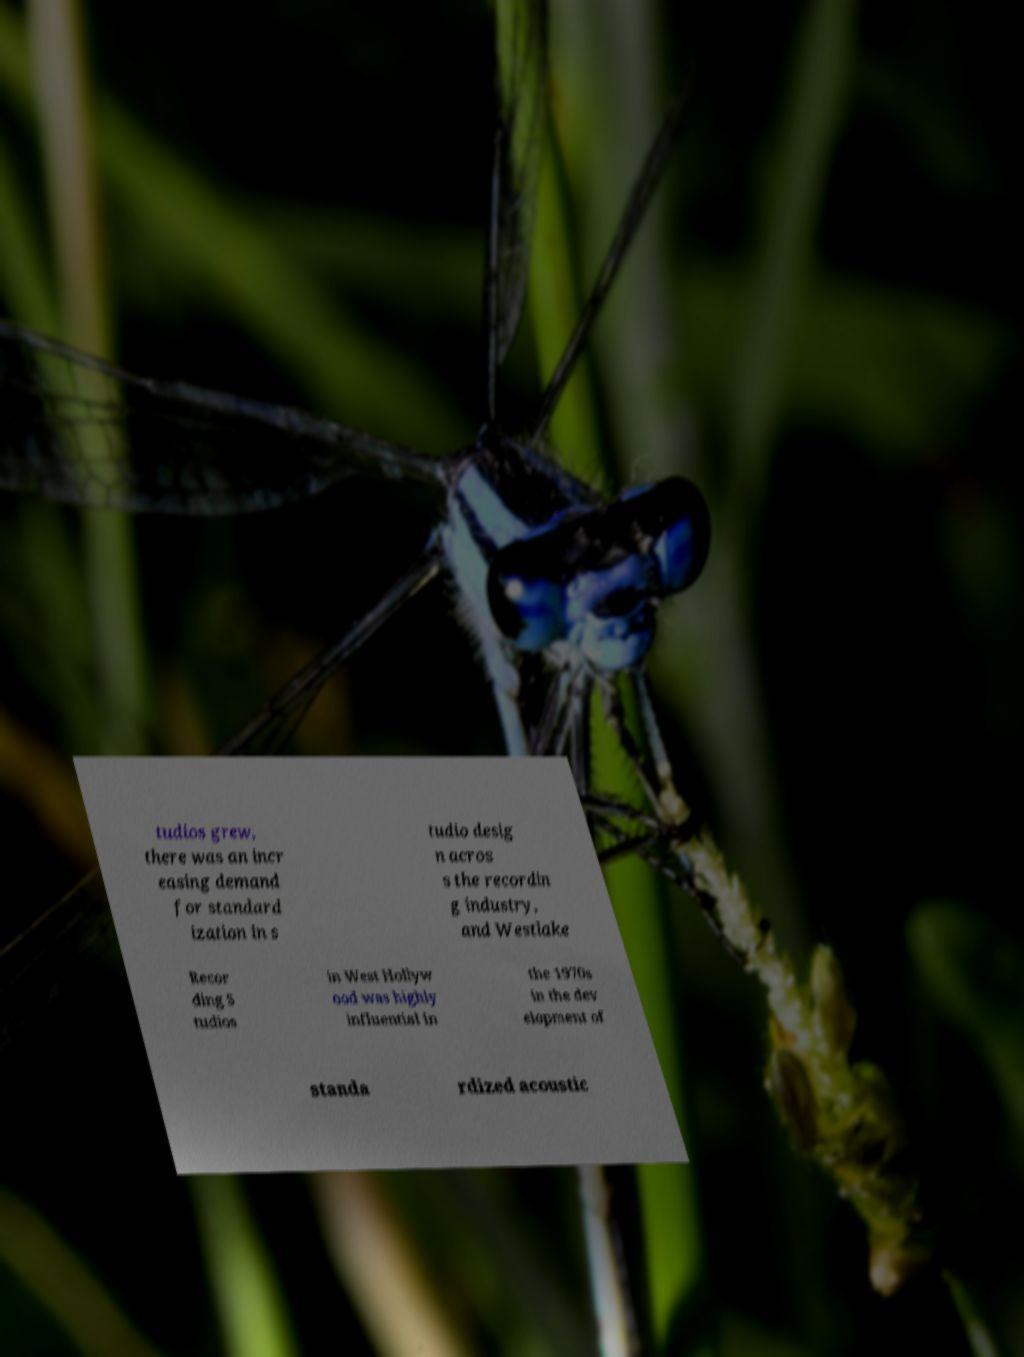I need the written content from this picture converted into text. Can you do that? tudios grew, there was an incr easing demand for standard ization in s tudio desig n acros s the recordin g industry, and Westlake Recor ding S tudios in West Hollyw ood was highly influential in the 1970s in the dev elopment of standa rdized acoustic 